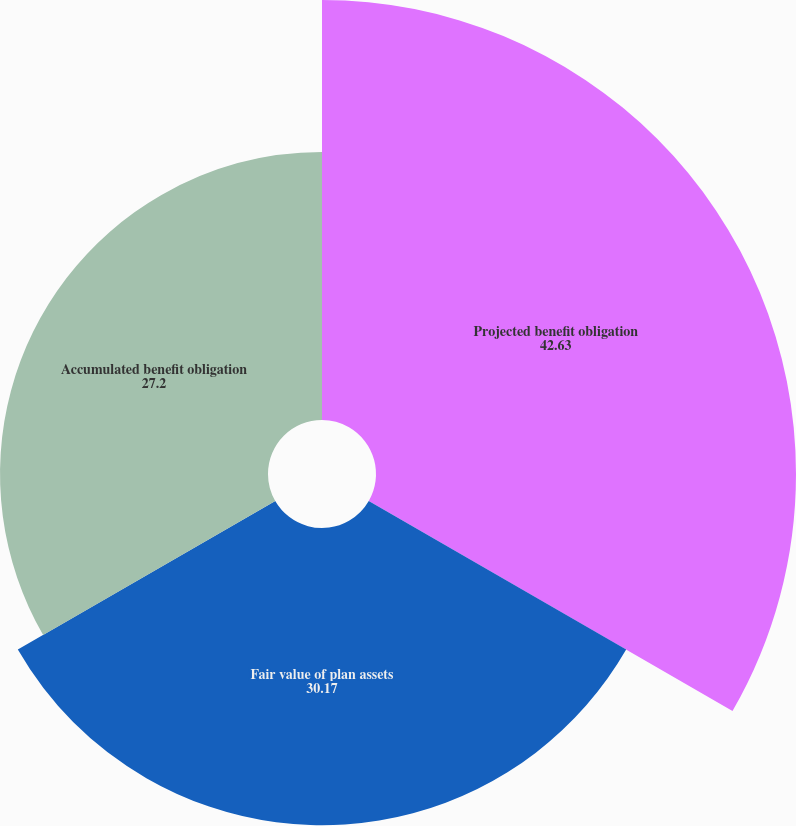<chart> <loc_0><loc_0><loc_500><loc_500><pie_chart><fcel>Projected benefit obligation<fcel>Fair value of plan assets<fcel>Accumulated benefit obligation<nl><fcel>42.63%<fcel>30.17%<fcel>27.2%<nl></chart> 